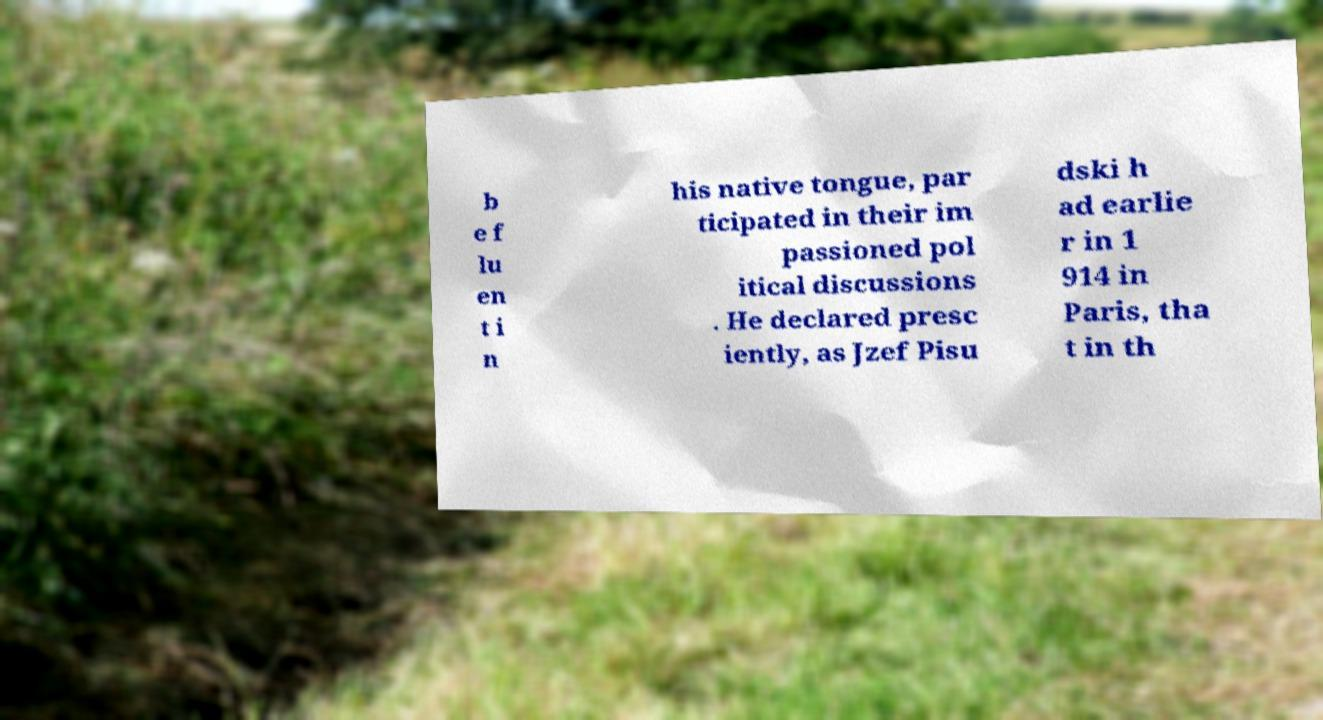Can you accurately transcribe the text from the provided image for me? b e f lu en t i n his native tongue, par ticipated in their im passioned pol itical discussions . He declared presc iently, as Jzef Pisu dski h ad earlie r in 1 914 in Paris, tha t in th 